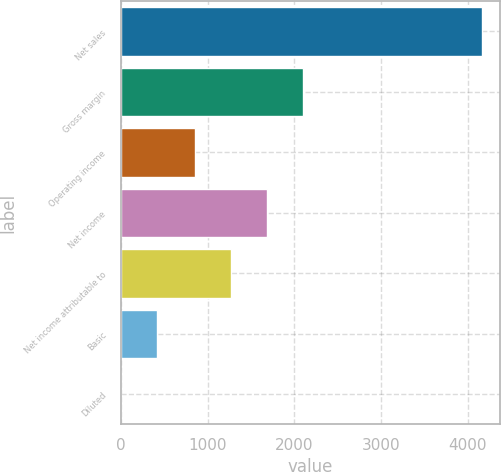<chart> <loc_0><loc_0><loc_500><loc_500><bar_chart><fcel>Net sales<fcel>Gross margin<fcel>Operating income<fcel>Net income<fcel>Net income attributable to<fcel>Basic<fcel>Diluted<nl><fcel>4166<fcel>2104.56<fcel>855<fcel>1688.04<fcel>1271.52<fcel>417.3<fcel>0.78<nl></chart> 